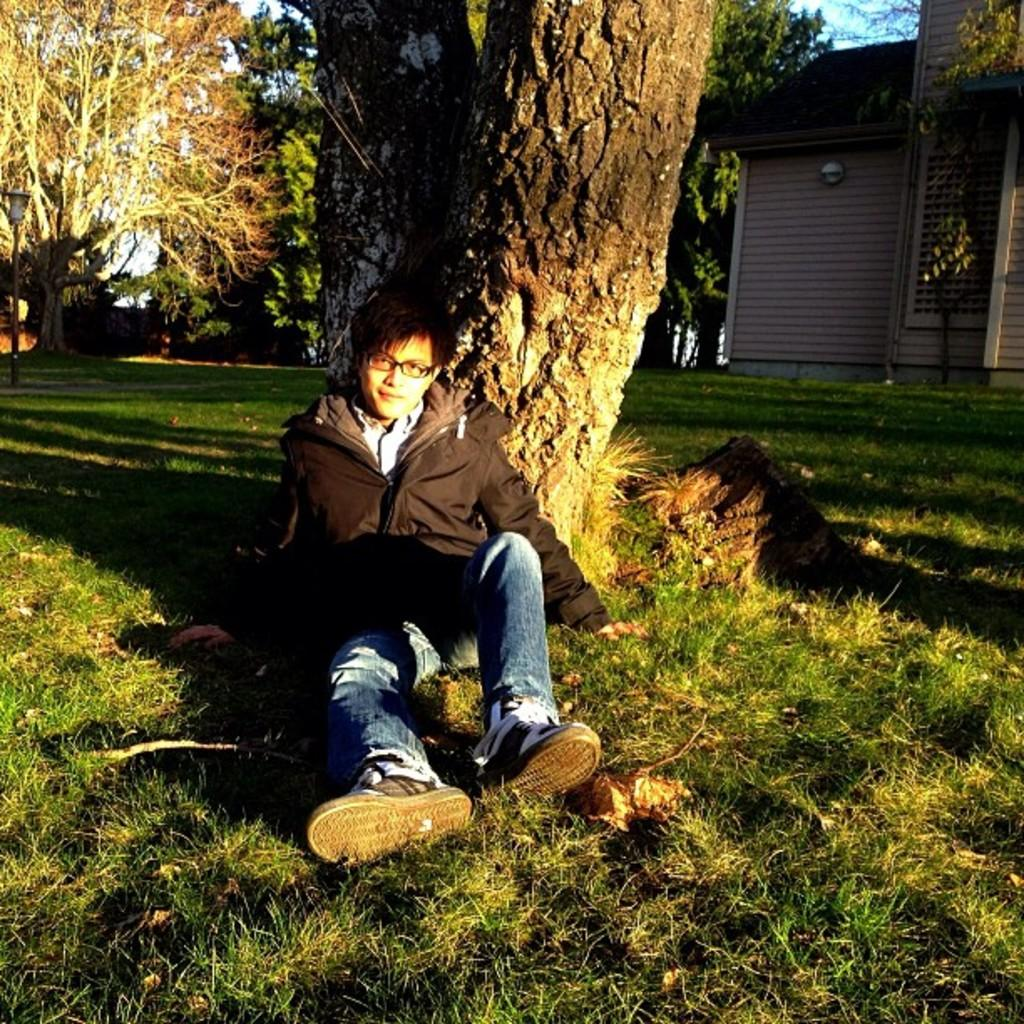What type of structure is present in the image? There is a house in the image. What can be seen in the background of the image? There are many trees and a grassy land in the image. Where is the person in the image located? The person is sitting on the grassy land in the image. What is visible above the trees and grassy land? There is a sky visible in the image. What type of locket is the lawyer holding in the image? There is no locket or lawyer present in the image. 